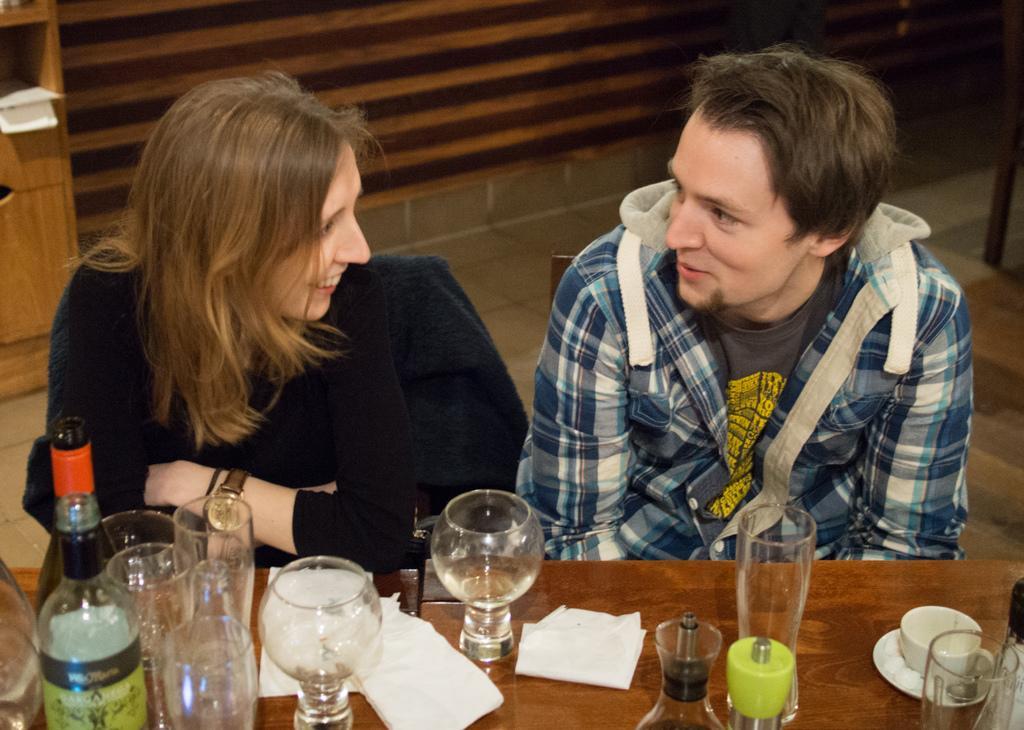Describe this image in one or two sentences. In this picture there is a man and a woman sitting on a chair. There is a bottle, cup, saucer, paper and glass on the table. 